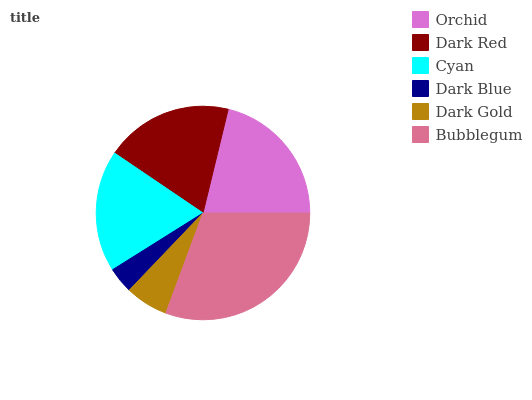Is Dark Blue the minimum?
Answer yes or no. Yes. Is Bubblegum the maximum?
Answer yes or no. Yes. Is Dark Red the minimum?
Answer yes or no. No. Is Dark Red the maximum?
Answer yes or no. No. Is Orchid greater than Dark Red?
Answer yes or no. Yes. Is Dark Red less than Orchid?
Answer yes or no. Yes. Is Dark Red greater than Orchid?
Answer yes or no. No. Is Orchid less than Dark Red?
Answer yes or no. No. Is Dark Red the high median?
Answer yes or no. Yes. Is Cyan the low median?
Answer yes or no. Yes. Is Orchid the high median?
Answer yes or no. No. Is Orchid the low median?
Answer yes or no. No. 